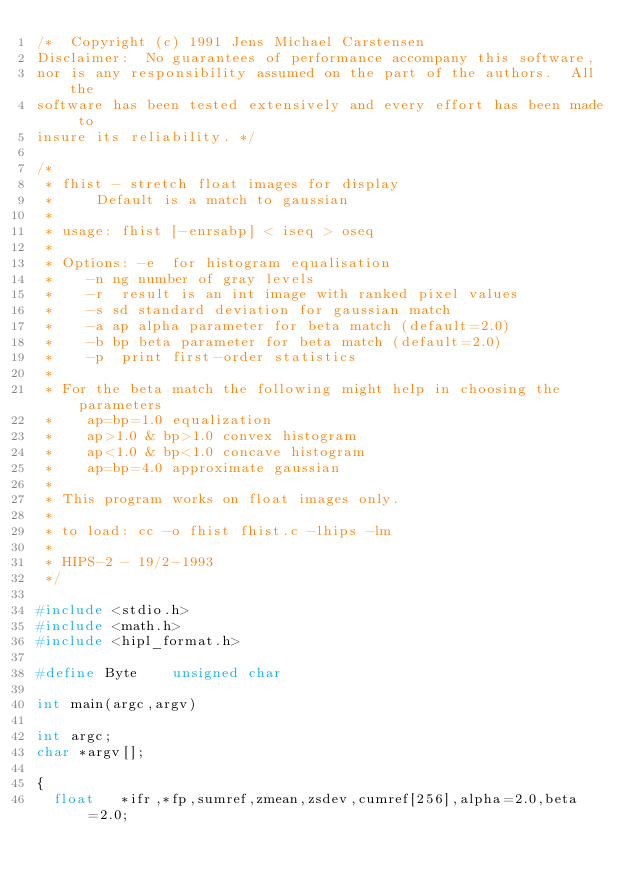<code> <loc_0><loc_0><loc_500><loc_500><_C_>/*	Copyright (c) 1991 Jens Michael Carstensen
Disclaimer:  No guarantees of performance accompany this software,
nor is any responsibility assumed on the part of the authors.  All the
software has been tested extensively and every effort has been made to
insure its reliability. */

/*
 * fhist - stretch float images for display
 *	   Default is a match to gaussian
 *
 * usage:	fhist [-enrsabp] < iseq > oseq
 *
 * Options:	-e	for histogram equalisation 
 *		-n ng	number of gray levels
 *		-r	result is an int image with ranked pixel values
 *		-s sd	standard deviation for gaussian match
 *		-a ap	alpha parameter for beta match (default=2.0)
 *		-b bp	beta parameter for beta match (default=2.0)
 *		-p	print first-order statistics
 *
 * For the beta match the following might help in choosing the parameters
 *		ap=bp=1.0	equalization
 *		ap>1.0 & bp>1.0 convex histogram
 *		ap<1.0 & bp<1.0 concave histogram
 *		ap=bp=4.0	approximate gaussian
 *
 * This program works on float images only.
 *
 * to load:	cc -o fhist fhist.c -lhips -lm
 *
 * HIPS-2 - 19/2-1993
 */

#include <stdio.h>
#include <math.h>
#include <hipl_format.h>

#define	Byte		unsigned char

int main(argc,argv)

int argc;
char *argv[];

{
	float 	*ifr,*fp,sumref,zmean,zsdev,cumref[256],alpha=2.0,beta=2.0;</code> 